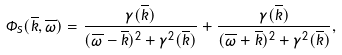Convert formula to latex. <formula><loc_0><loc_0><loc_500><loc_500>\Phi _ { S } ( \overline { k } , \overline { \omega } ) = \frac { \gamma ( \overline { k } ) } { ( \overline { \omega } - \overline { k } ) ^ { 2 } + \gamma ^ { 2 } ( \overline { k } ) } + \frac { \gamma ( \overline { k } ) } { ( \overline { \omega } + \overline { k } ) ^ { 2 } + \gamma ^ { 2 } ( \overline { k } ) } ,</formula> 